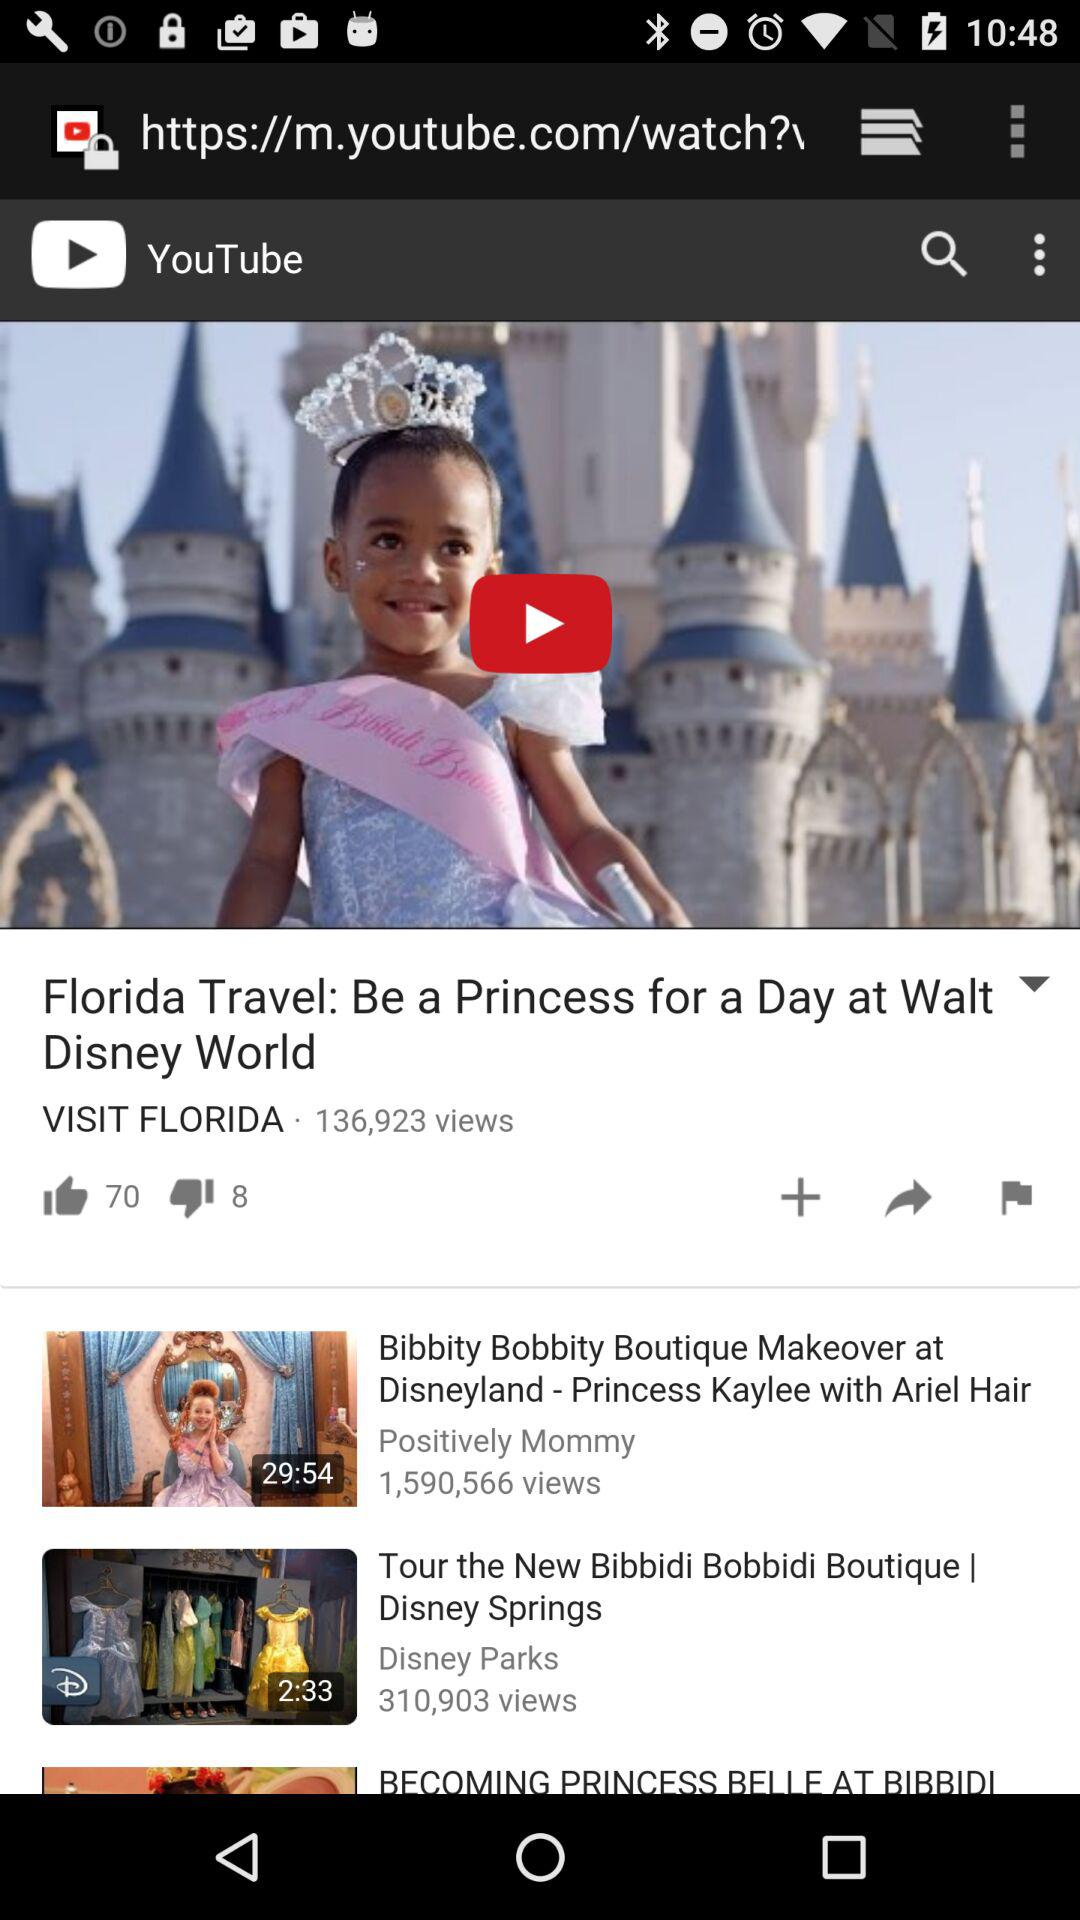How many likes are there on the "Florida Travel" video? There are 70 likes on the "Florida Travel" video. 